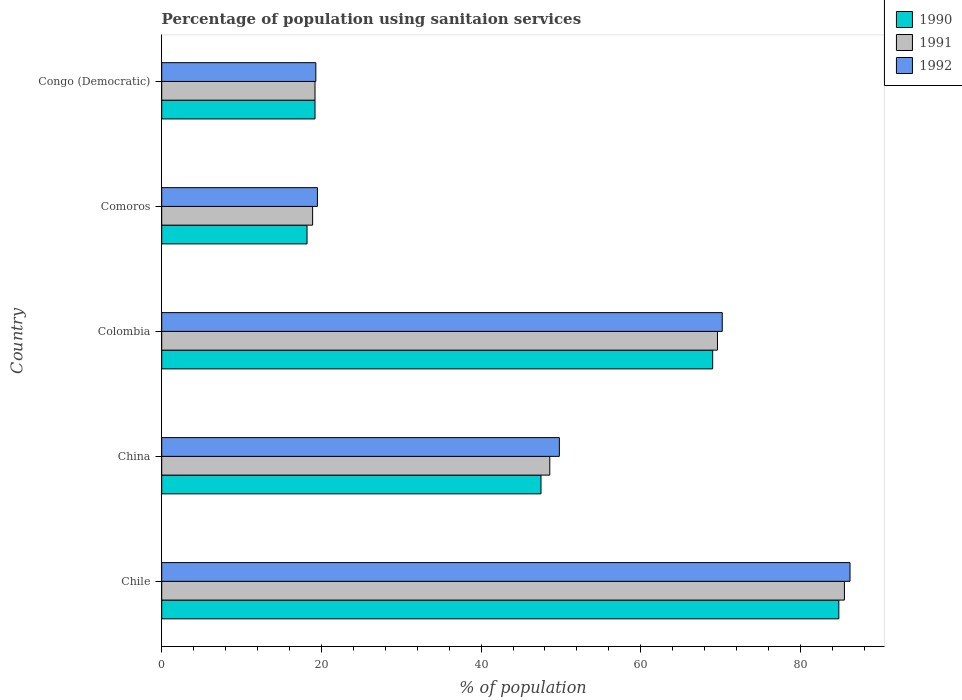How many different coloured bars are there?
Offer a very short reply. 3. How many groups of bars are there?
Your response must be concise. 5. How many bars are there on the 4th tick from the top?
Offer a terse response. 3. What is the label of the 1st group of bars from the top?
Make the answer very short. Congo (Democratic). In how many cases, is the number of bars for a given country not equal to the number of legend labels?
Offer a very short reply. 0. What is the percentage of population using sanitaion services in 1990 in Congo (Democratic)?
Provide a succinct answer. 19.2. Across all countries, what is the maximum percentage of population using sanitaion services in 1990?
Offer a very short reply. 84.8. Across all countries, what is the minimum percentage of population using sanitaion services in 1992?
Your answer should be compact. 19.3. In which country was the percentage of population using sanitaion services in 1990 minimum?
Your answer should be compact. Comoros. What is the total percentage of population using sanitaion services in 1990 in the graph?
Your response must be concise. 238.7. What is the difference between the percentage of population using sanitaion services in 1992 in China and that in Comoros?
Keep it short and to the point. 30.3. What is the difference between the percentage of population using sanitaion services in 1990 in China and the percentage of population using sanitaion services in 1992 in Chile?
Give a very brief answer. -38.7. What is the average percentage of population using sanitaion services in 1992 per country?
Provide a succinct answer. 49. What is the difference between the percentage of population using sanitaion services in 1990 and percentage of population using sanitaion services in 1991 in Colombia?
Your answer should be compact. -0.6. What is the ratio of the percentage of population using sanitaion services in 1992 in Chile to that in Comoros?
Your answer should be very brief. 4.42. Is the percentage of population using sanitaion services in 1990 in Colombia less than that in Congo (Democratic)?
Your response must be concise. No. What is the difference between the highest and the second highest percentage of population using sanitaion services in 1991?
Keep it short and to the point. 15.9. What is the difference between the highest and the lowest percentage of population using sanitaion services in 1990?
Your response must be concise. 66.6. Is the sum of the percentage of population using sanitaion services in 1992 in China and Comoros greater than the maximum percentage of population using sanitaion services in 1990 across all countries?
Give a very brief answer. No. What does the 2nd bar from the top in Chile represents?
Provide a short and direct response. 1991. What does the 3rd bar from the bottom in Chile represents?
Ensure brevity in your answer.  1992. How many bars are there?
Your answer should be compact. 15. Does the graph contain grids?
Make the answer very short. No. How are the legend labels stacked?
Ensure brevity in your answer.  Vertical. What is the title of the graph?
Provide a succinct answer. Percentage of population using sanitaion services. Does "1974" appear as one of the legend labels in the graph?
Your response must be concise. No. What is the label or title of the X-axis?
Your answer should be compact. % of population. What is the % of population in 1990 in Chile?
Provide a succinct answer. 84.8. What is the % of population of 1991 in Chile?
Your answer should be very brief. 85.5. What is the % of population in 1992 in Chile?
Ensure brevity in your answer.  86.2. What is the % of population of 1990 in China?
Ensure brevity in your answer.  47.5. What is the % of population of 1991 in China?
Provide a short and direct response. 48.6. What is the % of population in 1992 in China?
Keep it short and to the point. 49.8. What is the % of population in 1990 in Colombia?
Your response must be concise. 69. What is the % of population in 1991 in Colombia?
Keep it short and to the point. 69.6. What is the % of population in 1992 in Colombia?
Give a very brief answer. 70.2. What is the % of population of 1992 in Comoros?
Offer a very short reply. 19.5. What is the % of population of 1990 in Congo (Democratic)?
Keep it short and to the point. 19.2. What is the % of population in 1991 in Congo (Democratic)?
Provide a short and direct response. 19.2. What is the % of population of 1992 in Congo (Democratic)?
Ensure brevity in your answer.  19.3. Across all countries, what is the maximum % of population in 1990?
Your answer should be very brief. 84.8. Across all countries, what is the maximum % of population in 1991?
Provide a short and direct response. 85.5. Across all countries, what is the maximum % of population of 1992?
Offer a terse response. 86.2. Across all countries, what is the minimum % of population of 1990?
Provide a short and direct response. 18.2. Across all countries, what is the minimum % of population of 1992?
Provide a short and direct response. 19.3. What is the total % of population of 1990 in the graph?
Offer a very short reply. 238.7. What is the total % of population in 1991 in the graph?
Your response must be concise. 241.8. What is the total % of population of 1992 in the graph?
Your response must be concise. 245. What is the difference between the % of population of 1990 in Chile and that in China?
Give a very brief answer. 37.3. What is the difference between the % of population in 1991 in Chile and that in China?
Your answer should be compact. 36.9. What is the difference between the % of population of 1992 in Chile and that in China?
Your answer should be compact. 36.4. What is the difference between the % of population of 1990 in Chile and that in Colombia?
Offer a very short reply. 15.8. What is the difference between the % of population of 1992 in Chile and that in Colombia?
Offer a very short reply. 16. What is the difference between the % of population in 1990 in Chile and that in Comoros?
Ensure brevity in your answer.  66.6. What is the difference between the % of population in 1991 in Chile and that in Comoros?
Offer a very short reply. 66.6. What is the difference between the % of population in 1992 in Chile and that in Comoros?
Offer a terse response. 66.7. What is the difference between the % of population of 1990 in Chile and that in Congo (Democratic)?
Give a very brief answer. 65.6. What is the difference between the % of population of 1991 in Chile and that in Congo (Democratic)?
Give a very brief answer. 66.3. What is the difference between the % of population of 1992 in Chile and that in Congo (Democratic)?
Provide a short and direct response. 66.9. What is the difference between the % of population of 1990 in China and that in Colombia?
Provide a succinct answer. -21.5. What is the difference between the % of population in 1991 in China and that in Colombia?
Your response must be concise. -21. What is the difference between the % of population in 1992 in China and that in Colombia?
Offer a very short reply. -20.4. What is the difference between the % of population of 1990 in China and that in Comoros?
Give a very brief answer. 29.3. What is the difference between the % of population in 1991 in China and that in Comoros?
Your response must be concise. 29.7. What is the difference between the % of population in 1992 in China and that in Comoros?
Provide a short and direct response. 30.3. What is the difference between the % of population in 1990 in China and that in Congo (Democratic)?
Your answer should be compact. 28.3. What is the difference between the % of population in 1991 in China and that in Congo (Democratic)?
Ensure brevity in your answer.  29.4. What is the difference between the % of population of 1992 in China and that in Congo (Democratic)?
Provide a short and direct response. 30.5. What is the difference between the % of population of 1990 in Colombia and that in Comoros?
Offer a very short reply. 50.8. What is the difference between the % of population of 1991 in Colombia and that in Comoros?
Provide a succinct answer. 50.7. What is the difference between the % of population in 1992 in Colombia and that in Comoros?
Your response must be concise. 50.7. What is the difference between the % of population of 1990 in Colombia and that in Congo (Democratic)?
Ensure brevity in your answer.  49.8. What is the difference between the % of population of 1991 in Colombia and that in Congo (Democratic)?
Ensure brevity in your answer.  50.4. What is the difference between the % of population of 1992 in Colombia and that in Congo (Democratic)?
Make the answer very short. 50.9. What is the difference between the % of population in 1990 in Comoros and that in Congo (Democratic)?
Offer a terse response. -1. What is the difference between the % of population in 1992 in Comoros and that in Congo (Democratic)?
Your answer should be compact. 0.2. What is the difference between the % of population of 1990 in Chile and the % of population of 1991 in China?
Offer a very short reply. 36.2. What is the difference between the % of population of 1991 in Chile and the % of population of 1992 in China?
Your answer should be compact. 35.7. What is the difference between the % of population in 1990 in Chile and the % of population in 1992 in Colombia?
Offer a terse response. 14.6. What is the difference between the % of population of 1991 in Chile and the % of population of 1992 in Colombia?
Give a very brief answer. 15.3. What is the difference between the % of population in 1990 in Chile and the % of population in 1991 in Comoros?
Provide a succinct answer. 65.9. What is the difference between the % of population of 1990 in Chile and the % of population of 1992 in Comoros?
Ensure brevity in your answer.  65.3. What is the difference between the % of population in 1990 in Chile and the % of population in 1991 in Congo (Democratic)?
Your answer should be very brief. 65.6. What is the difference between the % of population of 1990 in Chile and the % of population of 1992 in Congo (Democratic)?
Give a very brief answer. 65.5. What is the difference between the % of population of 1991 in Chile and the % of population of 1992 in Congo (Democratic)?
Ensure brevity in your answer.  66.2. What is the difference between the % of population of 1990 in China and the % of population of 1991 in Colombia?
Offer a terse response. -22.1. What is the difference between the % of population in 1990 in China and the % of population in 1992 in Colombia?
Your answer should be compact. -22.7. What is the difference between the % of population in 1991 in China and the % of population in 1992 in Colombia?
Keep it short and to the point. -21.6. What is the difference between the % of population in 1990 in China and the % of population in 1991 in Comoros?
Your answer should be compact. 28.6. What is the difference between the % of population in 1991 in China and the % of population in 1992 in Comoros?
Provide a short and direct response. 29.1. What is the difference between the % of population in 1990 in China and the % of population in 1991 in Congo (Democratic)?
Your answer should be compact. 28.3. What is the difference between the % of population of 1990 in China and the % of population of 1992 in Congo (Democratic)?
Your response must be concise. 28.2. What is the difference between the % of population in 1991 in China and the % of population in 1992 in Congo (Democratic)?
Ensure brevity in your answer.  29.3. What is the difference between the % of population in 1990 in Colombia and the % of population in 1991 in Comoros?
Your response must be concise. 50.1. What is the difference between the % of population of 1990 in Colombia and the % of population of 1992 in Comoros?
Your answer should be compact. 49.5. What is the difference between the % of population of 1991 in Colombia and the % of population of 1992 in Comoros?
Keep it short and to the point. 50.1. What is the difference between the % of population in 1990 in Colombia and the % of population in 1991 in Congo (Democratic)?
Your answer should be compact. 49.8. What is the difference between the % of population of 1990 in Colombia and the % of population of 1992 in Congo (Democratic)?
Ensure brevity in your answer.  49.7. What is the difference between the % of population of 1991 in Colombia and the % of population of 1992 in Congo (Democratic)?
Offer a very short reply. 50.3. What is the difference between the % of population of 1991 in Comoros and the % of population of 1992 in Congo (Democratic)?
Give a very brief answer. -0.4. What is the average % of population in 1990 per country?
Give a very brief answer. 47.74. What is the average % of population in 1991 per country?
Give a very brief answer. 48.36. What is the difference between the % of population of 1990 and % of population of 1991 in Chile?
Your answer should be very brief. -0.7. What is the difference between the % of population of 1990 and % of population of 1992 in Chile?
Ensure brevity in your answer.  -1.4. What is the difference between the % of population in 1991 and % of population in 1992 in Chile?
Offer a terse response. -0.7. What is the difference between the % of population of 1990 and % of population of 1991 in Colombia?
Offer a terse response. -0.6. What is the difference between the % of population in 1991 and % of population in 1992 in Colombia?
Ensure brevity in your answer.  -0.6. What is the difference between the % of population in 1990 and % of population in 1991 in Comoros?
Give a very brief answer. -0.7. What is the difference between the % of population in 1990 and % of population in 1992 in Comoros?
Give a very brief answer. -1.3. What is the difference between the % of population in 1991 and % of population in 1992 in Congo (Democratic)?
Make the answer very short. -0.1. What is the ratio of the % of population in 1990 in Chile to that in China?
Give a very brief answer. 1.79. What is the ratio of the % of population of 1991 in Chile to that in China?
Your answer should be compact. 1.76. What is the ratio of the % of population of 1992 in Chile to that in China?
Your response must be concise. 1.73. What is the ratio of the % of population of 1990 in Chile to that in Colombia?
Your response must be concise. 1.23. What is the ratio of the % of population of 1991 in Chile to that in Colombia?
Your answer should be compact. 1.23. What is the ratio of the % of population of 1992 in Chile to that in Colombia?
Your response must be concise. 1.23. What is the ratio of the % of population in 1990 in Chile to that in Comoros?
Give a very brief answer. 4.66. What is the ratio of the % of population in 1991 in Chile to that in Comoros?
Your answer should be very brief. 4.52. What is the ratio of the % of population of 1992 in Chile to that in Comoros?
Provide a short and direct response. 4.42. What is the ratio of the % of population of 1990 in Chile to that in Congo (Democratic)?
Make the answer very short. 4.42. What is the ratio of the % of population of 1991 in Chile to that in Congo (Democratic)?
Keep it short and to the point. 4.45. What is the ratio of the % of population of 1992 in Chile to that in Congo (Democratic)?
Your answer should be very brief. 4.47. What is the ratio of the % of population of 1990 in China to that in Colombia?
Keep it short and to the point. 0.69. What is the ratio of the % of population of 1991 in China to that in Colombia?
Provide a succinct answer. 0.7. What is the ratio of the % of population of 1992 in China to that in Colombia?
Offer a terse response. 0.71. What is the ratio of the % of population in 1990 in China to that in Comoros?
Offer a very short reply. 2.61. What is the ratio of the % of population of 1991 in China to that in Comoros?
Offer a terse response. 2.57. What is the ratio of the % of population in 1992 in China to that in Comoros?
Make the answer very short. 2.55. What is the ratio of the % of population in 1990 in China to that in Congo (Democratic)?
Your answer should be compact. 2.47. What is the ratio of the % of population of 1991 in China to that in Congo (Democratic)?
Keep it short and to the point. 2.53. What is the ratio of the % of population in 1992 in China to that in Congo (Democratic)?
Provide a short and direct response. 2.58. What is the ratio of the % of population of 1990 in Colombia to that in Comoros?
Provide a short and direct response. 3.79. What is the ratio of the % of population of 1991 in Colombia to that in Comoros?
Keep it short and to the point. 3.68. What is the ratio of the % of population in 1990 in Colombia to that in Congo (Democratic)?
Your answer should be compact. 3.59. What is the ratio of the % of population of 1991 in Colombia to that in Congo (Democratic)?
Your answer should be compact. 3.62. What is the ratio of the % of population in 1992 in Colombia to that in Congo (Democratic)?
Ensure brevity in your answer.  3.64. What is the ratio of the % of population in 1990 in Comoros to that in Congo (Democratic)?
Provide a short and direct response. 0.95. What is the ratio of the % of population in 1991 in Comoros to that in Congo (Democratic)?
Offer a very short reply. 0.98. What is the ratio of the % of population in 1992 in Comoros to that in Congo (Democratic)?
Offer a terse response. 1.01. What is the difference between the highest and the second highest % of population of 1991?
Your answer should be compact. 15.9. What is the difference between the highest and the lowest % of population of 1990?
Offer a very short reply. 66.6. What is the difference between the highest and the lowest % of population of 1991?
Your response must be concise. 66.6. What is the difference between the highest and the lowest % of population of 1992?
Ensure brevity in your answer.  66.9. 